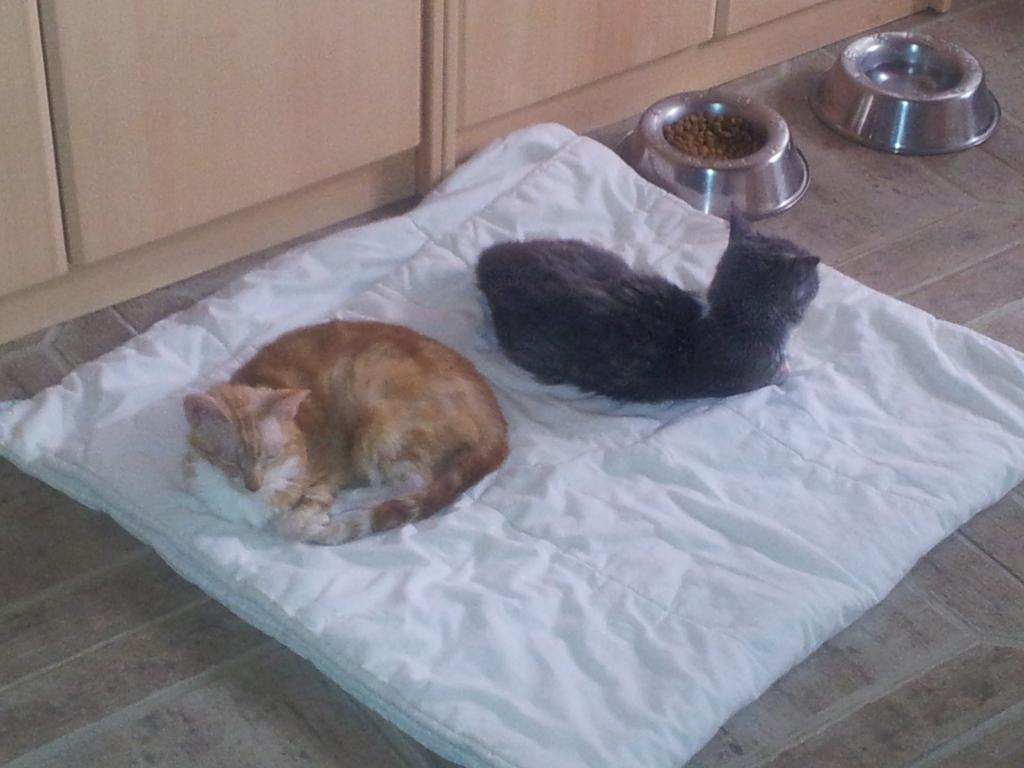What animals are in the center of the picture? There are two cats in the center of the picture. What are the cats sitting on? The cats are on a cat bed. What objects can be seen on the right side of the image? There are two bowls on the right side of the image. What type of furniture is visible at the top of the image? There are closets at the top of the image. Can you hear the cats laughing in the image? The image is silent, and there is no indication that the cats are laughing. What type of canvas is used for the cat bed in the image? There is no mention of a canvas in the image; the cat bed appears to be made of fabric or other materials. 